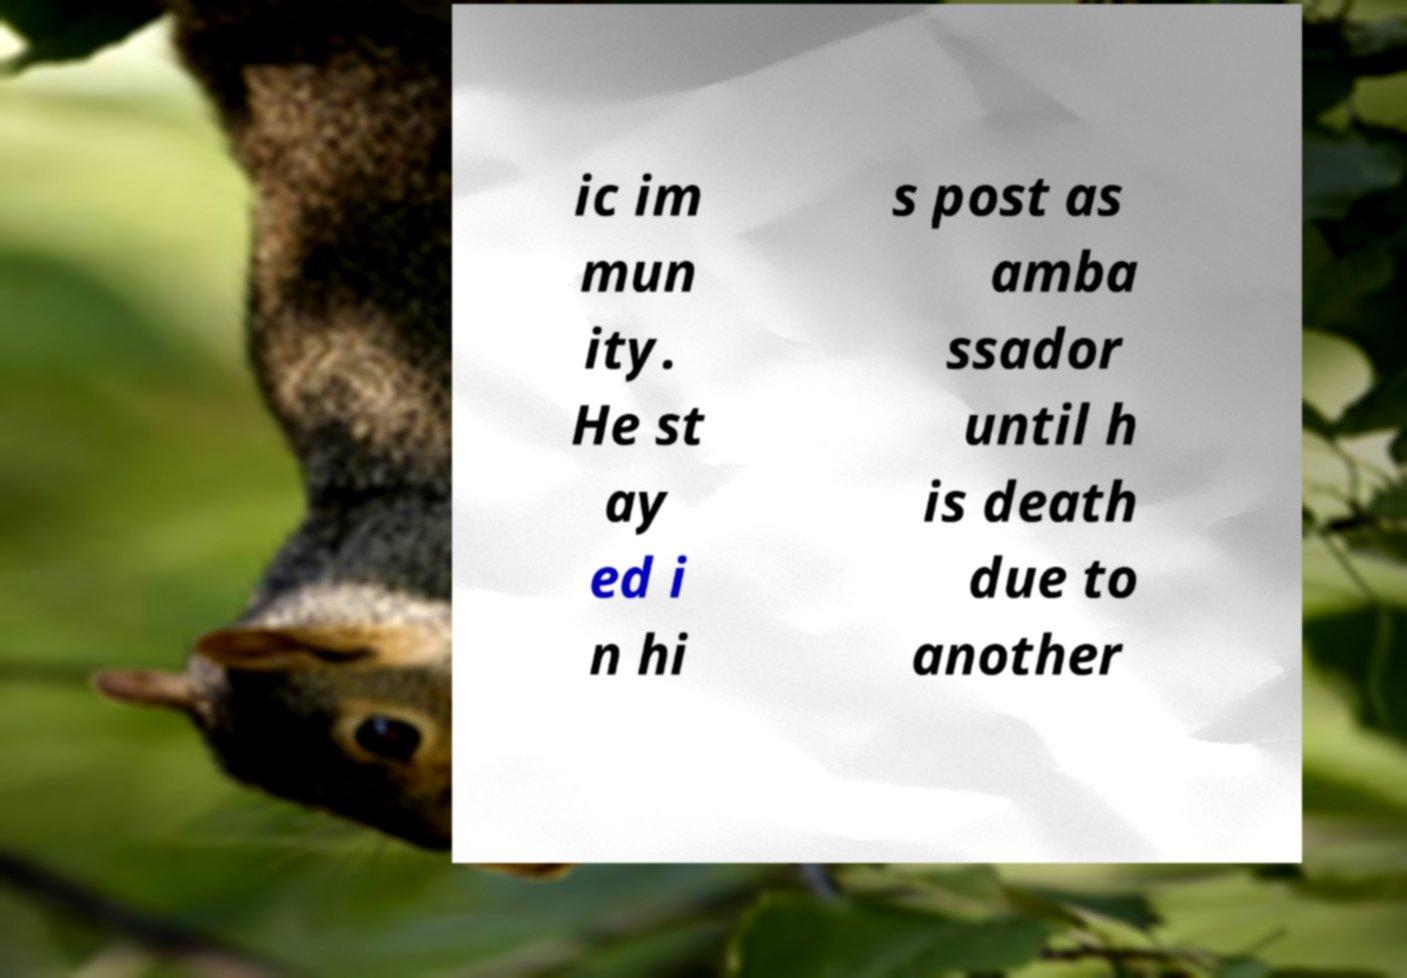I need the written content from this picture converted into text. Can you do that? ic im mun ity. He st ay ed i n hi s post as amba ssador until h is death due to another 